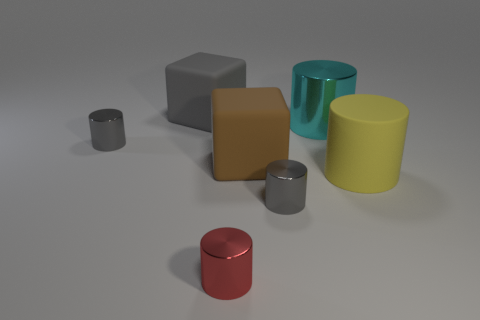What color is the other cylinder that is the same size as the yellow matte cylinder? Apart from the yellow matte cylinder, there is another cylinder of the same size that has a cyan finish. This color can be described as a light blue-green, similar to the color of tropical waters seen on a clear sunny day. 